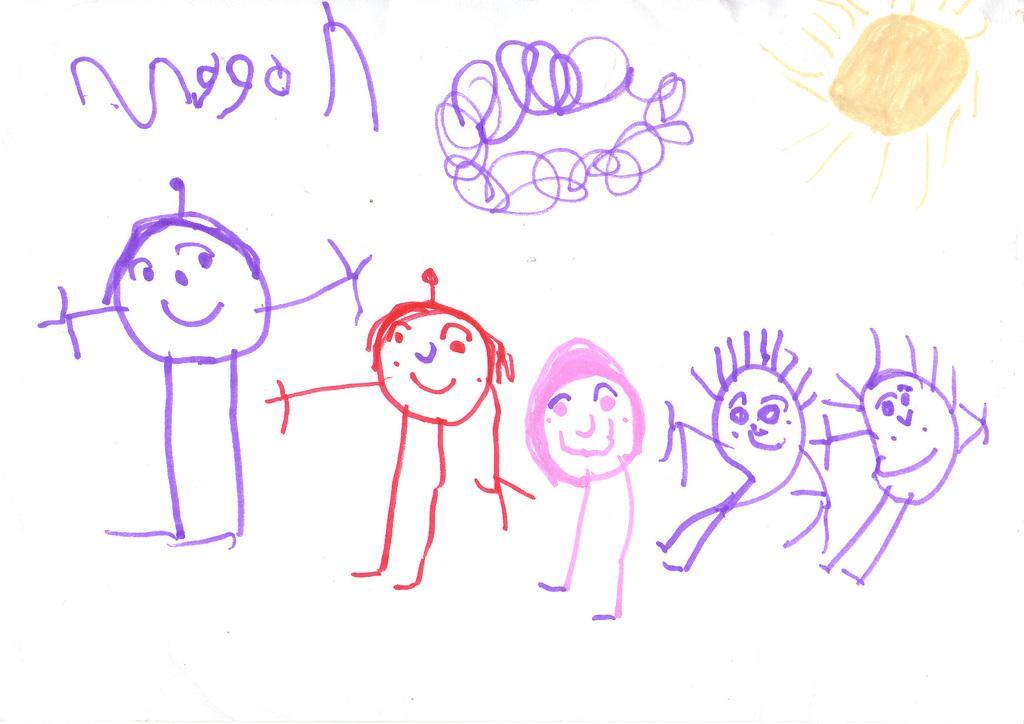In one or two sentences, can you explain what this image depicts? There are sketches of persons and other objects on the white color surface. And the background is white in color. 